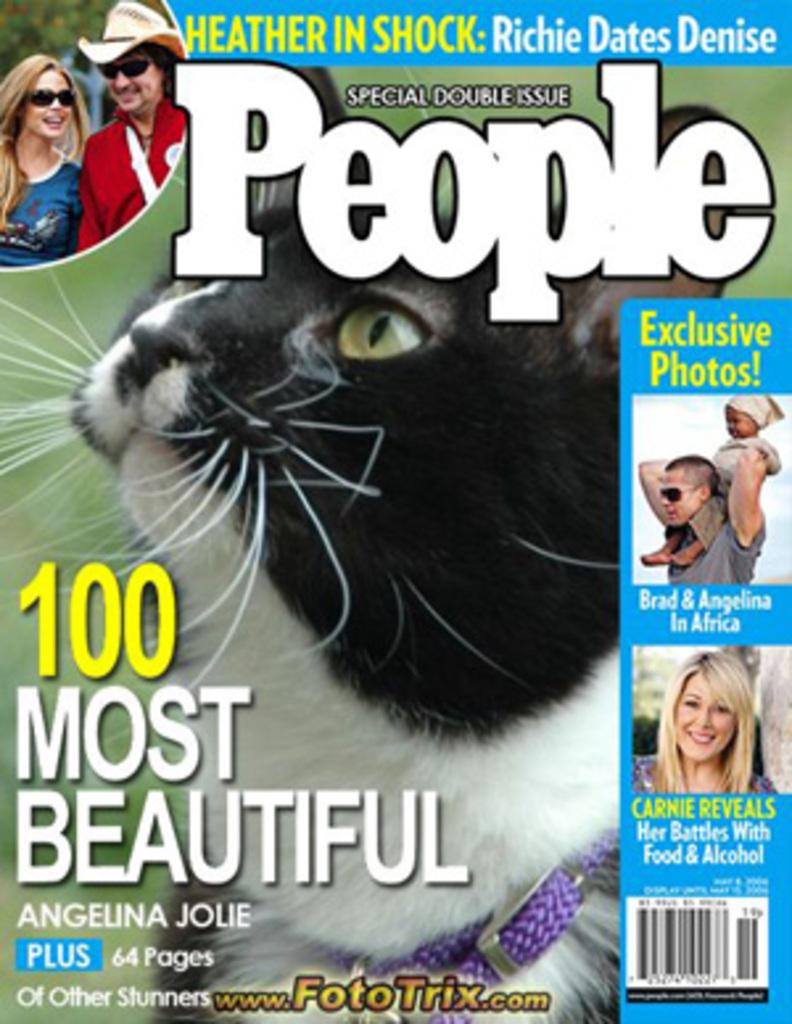What is the main object in the image? There is a pamphlet in the image. What type of image can be seen on the pamphlet? The pamphlet contains a picture of a cat. Are there any other images on the pamphlet besides the cat? Yes, the pamphlet contains pictures of people. What else can be found on the pamphlet besides images? There is text written on the pamphlet. What type of string is being used to catch fish in the image? There is no string or fishing activity present in the image; it features a pamphlet with images and text. Can you tell me how many streams are visible in the image? There are no streams visible in the image; it features a pamphlet with images and text. 